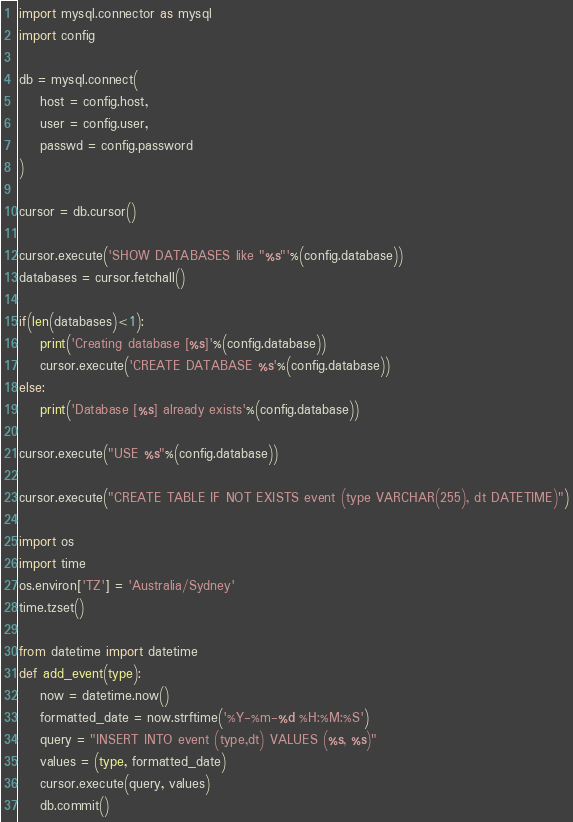<code> <loc_0><loc_0><loc_500><loc_500><_Python_>import mysql.connector as mysql
import config

db = mysql.connect(
    host = config.host,
    user = config.user,
    passwd = config.password
)

cursor = db.cursor()

cursor.execute('SHOW DATABASES like "%s"'%(config.database))
databases = cursor.fetchall()

if(len(databases)<1):
    print('Creating database [%s]'%(config.database))
    cursor.execute('CREATE DATABASE %s'%(config.database))
else:
    print('Database [%s] already exists'%(config.database))

cursor.execute("USE %s"%(config.database))

cursor.execute("CREATE TABLE IF NOT EXISTS event (type VARCHAR(255), dt DATETIME)")

import os
import time
os.environ['TZ'] = 'Australia/Sydney'
time.tzset()

from datetime import datetime
def add_event(type):
    now = datetime.now()
    formatted_date = now.strftime('%Y-%m-%d %H:%M:%S')
    query = "INSERT INTO event (type,dt) VALUES (%s, %s)"
    values = (type, formatted_date)
    cursor.execute(query, values)
    db.commit()
</code> 